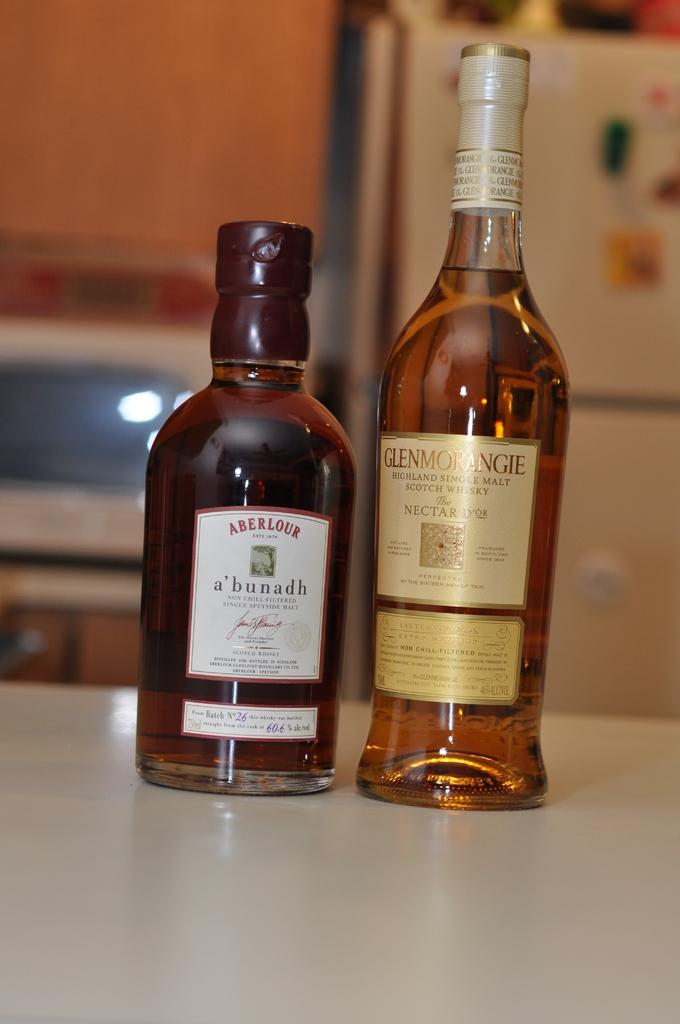<image>
Write a terse but informative summary of the picture. Two bottles of alcohol, one from Aberlour and the other from Glenmorangie. 